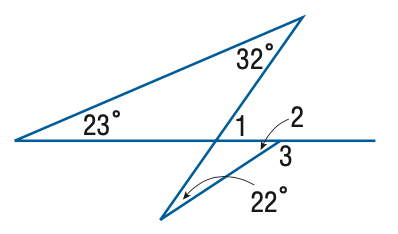Answer the mathemtical geometry problem and directly provide the correct option letter.
Question: Find the measure of \angle 1.
Choices: A: 33 B: 45 C: 54 D: 55 D 